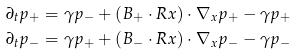Convert formula to latex. <formula><loc_0><loc_0><loc_500><loc_500>\partial _ { t } p _ { + } & = \gamma p _ { - } + ( { B } _ { + } \cdot { R } { x } ) \cdot \nabla _ { x } p _ { + } - \gamma p _ { + } \\ \partial _ { t } p _ { - } & = \gamma p _ { + } + ( { B } _ { - } \cdot { R } { x } ) \cdot \nabla _ { x } p _ { - } - \gamma p _ { - }</formula> 